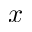<formula> <loc_0><loc_0><loc_500><loc_500>x</formula> 